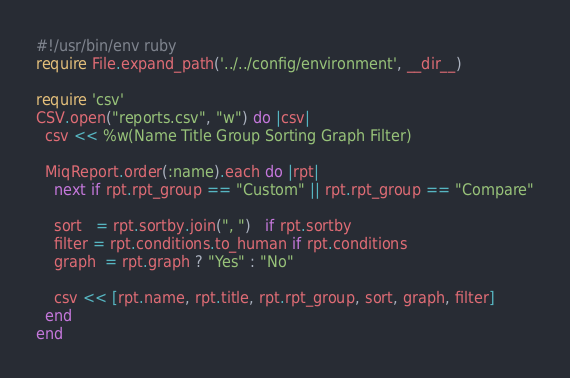<code> <loc_0><loc_0><loc_500><loc_500><_Ruby_>#!/usr/bin/env ruby
require File.expand_path('../../config/environment', __dir__)

require 'csv'
CSV.open("reports.csv", "w") do |csv|
  csv << %w(Name Title Group Sorting Graph Filter)

  MiqReport.order(:name).each do |rpt|
    next if rpt.rpt_group == "Custom" || rpt.rpt_group == "Compare"

    sort   = rpt.sortby.join(", ")   if rpt.sortby
    filter = rpt.conditions.to_human if rpt.conditions
    graph  = rpt.graph ? "Yes" : "No"

    csv << [rpt.name, rpt.title, rpt.rpt_group, sort, graph, filter]
  end
end
</code> 